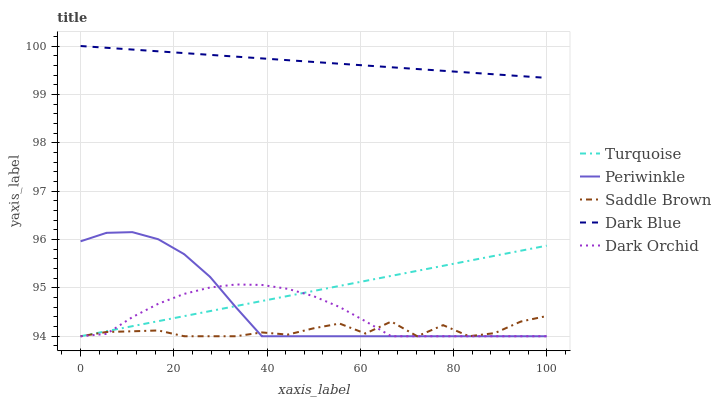Does Saddle Brown have the minimum area under the curve?
Answer yes or no. Yes. Does Dark Blue have the maximum area under the curve?
Answer yes or no. Yes. Does Turquoise have the minimum area under the curve?
Answer yes or no. No. Does Turquoise have the maximum area under the curve?
Answer yes or no. No. Is Dark Blue the smoothest?
Answer yes or no. Yes. Is Saddle Brown the roughest?
Answer yes or no. Yes. Is Turquoise the smoothest?
Answer yes or no. No. Is Turquoise the roughest?
Answer yes or no. No. Does Dark Blue have the highest value?
Answer yes or no. Yes. Does Turquoise have the highest value?
Answer yes or no. No. Is Dark Orchid less than Dark Blue?
Answer yes or no. Yes. Is Dark Blue greater than Turquoise?
Answer yes or no. Yes. Does Saddle Brown intersect Periwinkle?
Answer yes or no. Yes. Is Saddle Brown less than Periwinkle?
Answer yes or no. No. Is Saddle Brown greater than Periwinkle?
Answer yes or no. No. Does Dark Orchid intersect Dark Blue?
Answer yes or no. No. 